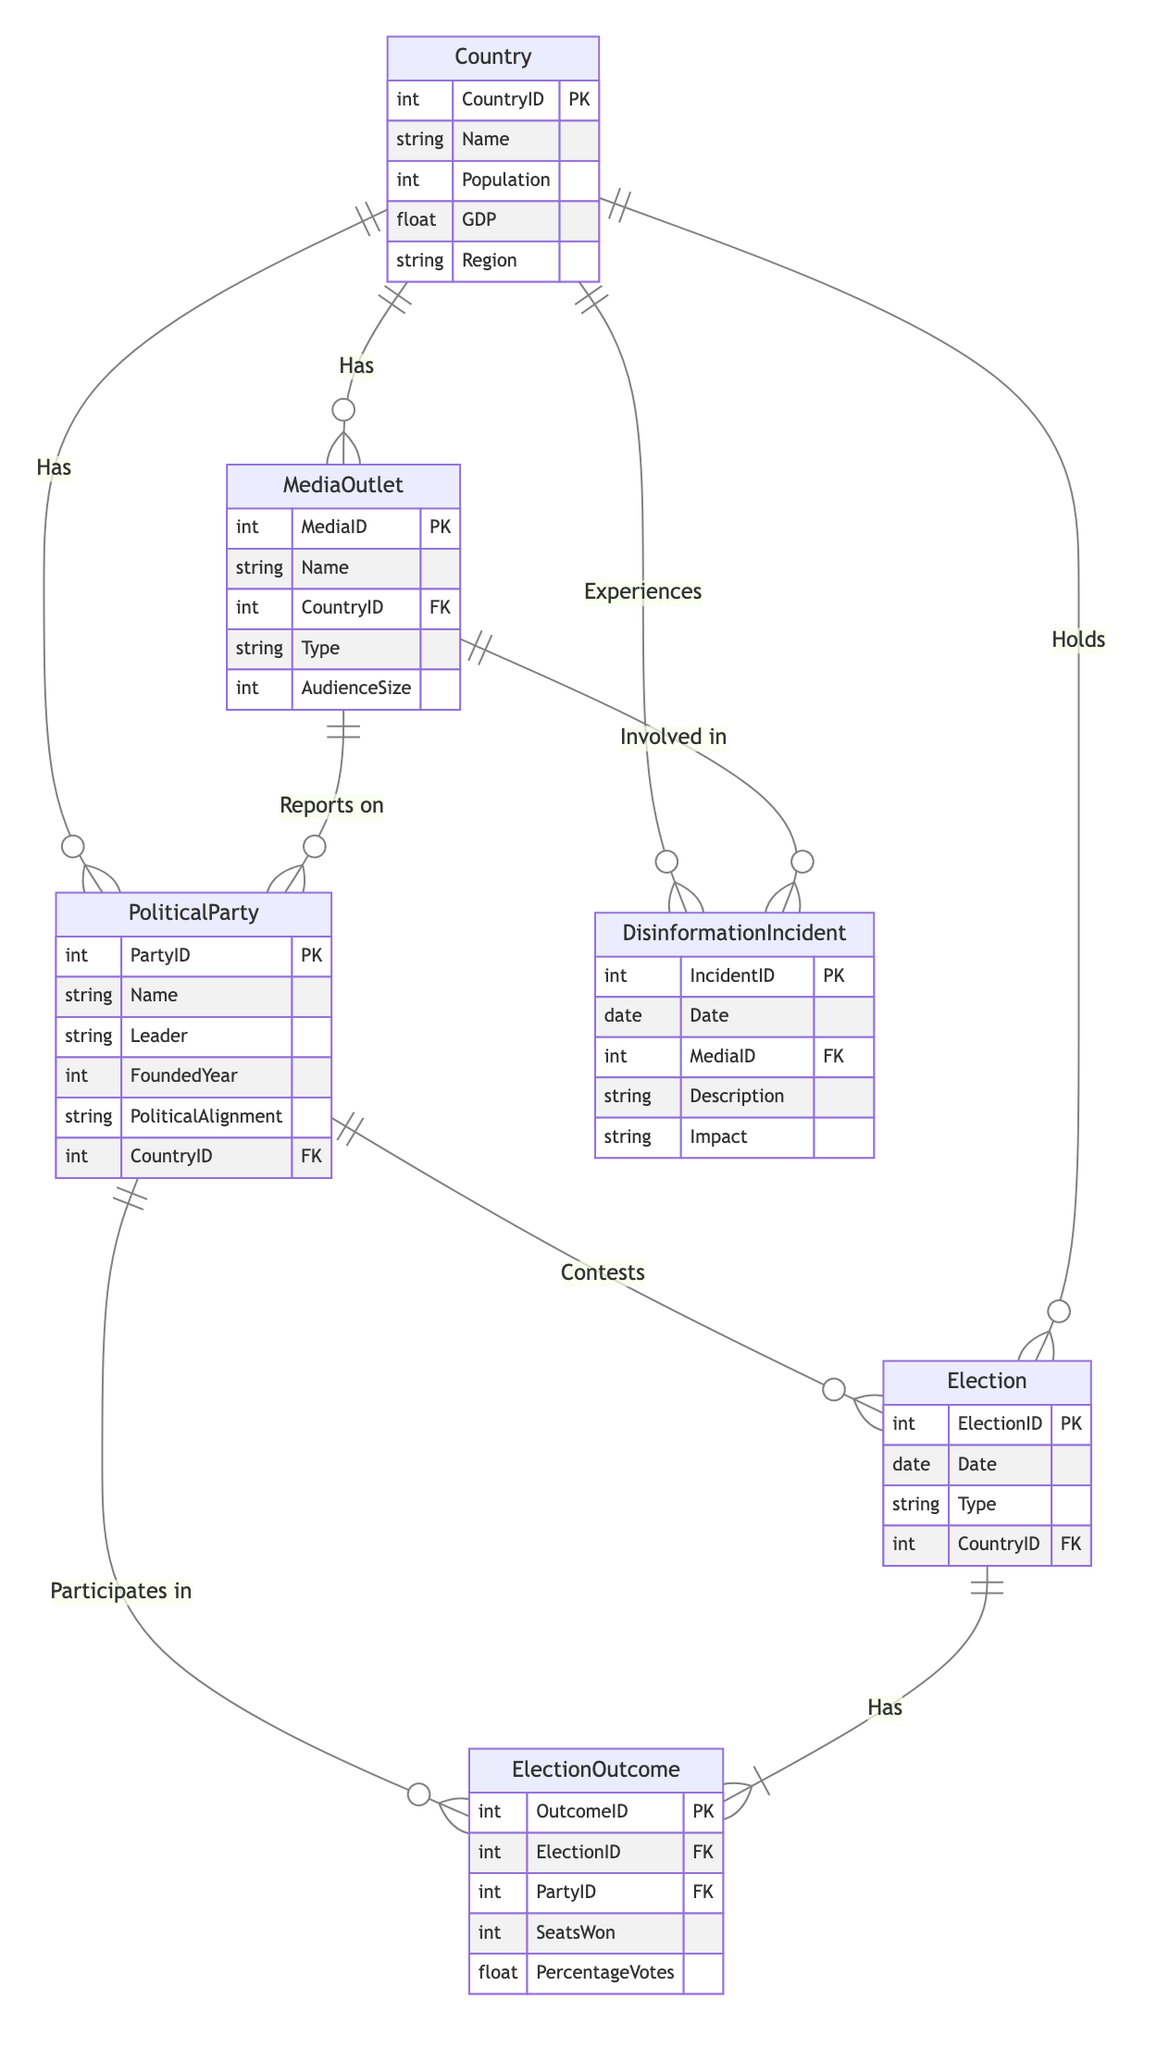What is the primary key for the PoliticalParty entity? The primary key is represented as PK in the diagram's listing of attributes. In the PoliticalParty entity, the attribute labeled as PartyID is marked as PK, indicating it is the primary key.
Answer: PartyID How many attributes does the ElectionOutcome entity have? By examining the ElectionOutcome entity in the diagram, we count the attributes listed: OutcomeID, ElectionID, PartyID, SeatsWon, PercentageVotes. This gives us a total of five attributes.
Answer: 5 What relationship connects PoliticalParty and Election? In the diagram, the relationship from PoliticalParty to Election is labeled as "Contests." It indicates participation in elections by political parties.
Answer: Contests Which entity is connected to MediaOutlet via the relationship "Reports On"? The diagram shows that there is a relationship named "Reports On" between the MediaOutlet entity and the PoliticalParty entity, implying that media outlets report on political parties.
Answer: PoliticalParty What is the relationship called between Election and ElectionOutcome? The diagram illustrates a relationship from Election to ElectionOutcome labeled "Has." This signifies that each election has associated outcomes that detail performance by political parties.
Answer: Has How many different types of entities are represented in this diagram? Analyzing the entities listed in the diagram, we identify six distinct types: PoliticalParty, Election, ElectionOutcome, Country, MediaOutlet, and DisinformationIncident. Therefore, the total count is six.
Answer: 6 What is the foreign key in the Election entity? In the diagram, the Election entity contains a foreign key, indicated as FK, called CountryID. This establishes a link to the Country entity by referring to its primary key.
Answer: CountryID Which entity experiences disinformation incidents according to the diagram? The diagram specifies that the Country entity has a relationship where it "Experiences" disinformation incidents. This means that incidents occur in the context of a country.
Answer: Country What type of relationship exists between Country and DisinformationIncident? The diagram illustrates a relationship labeled "Experiences" connecting the Country entity to the DisinformationIncident entity, indicating that countries undergo or face disinformation events.
Answer: Experiences 